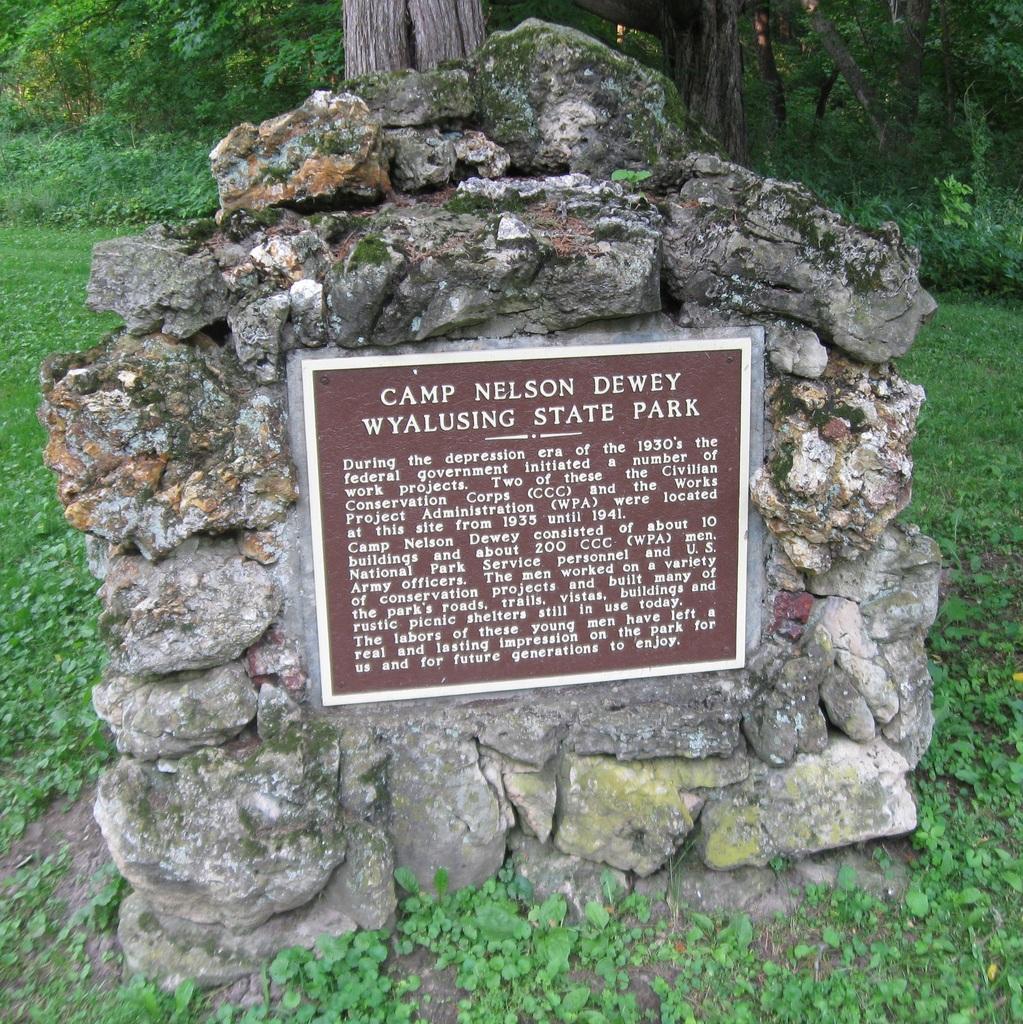Please provide a concise description of this image. In this picture I can see stone object on which something written on it. In the background I can see trees and grass. 